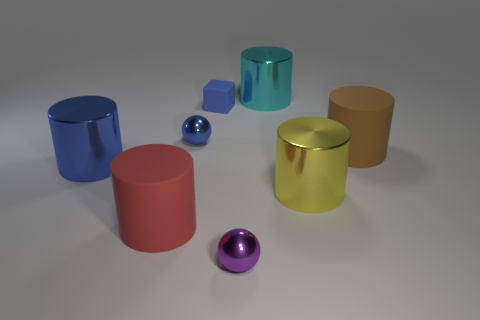Are the objects arranged in a particular pattern? The objects are scattered randomly with no discernible pattern. They seem to be positioned on a flat surface with adequate space between them. 